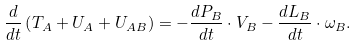<formula> <loc_0><loc_0><loc_500><loc_500>\frac { d } { d t } \left ( T _ { A } + U _ { A } + U _ { A B } \right ) = - \frac { d P _ { B } } { d t } \cdot V _ { B } - \frac { d L _ { B } } { d t } \cdot \omega _ { B } .</formula> 